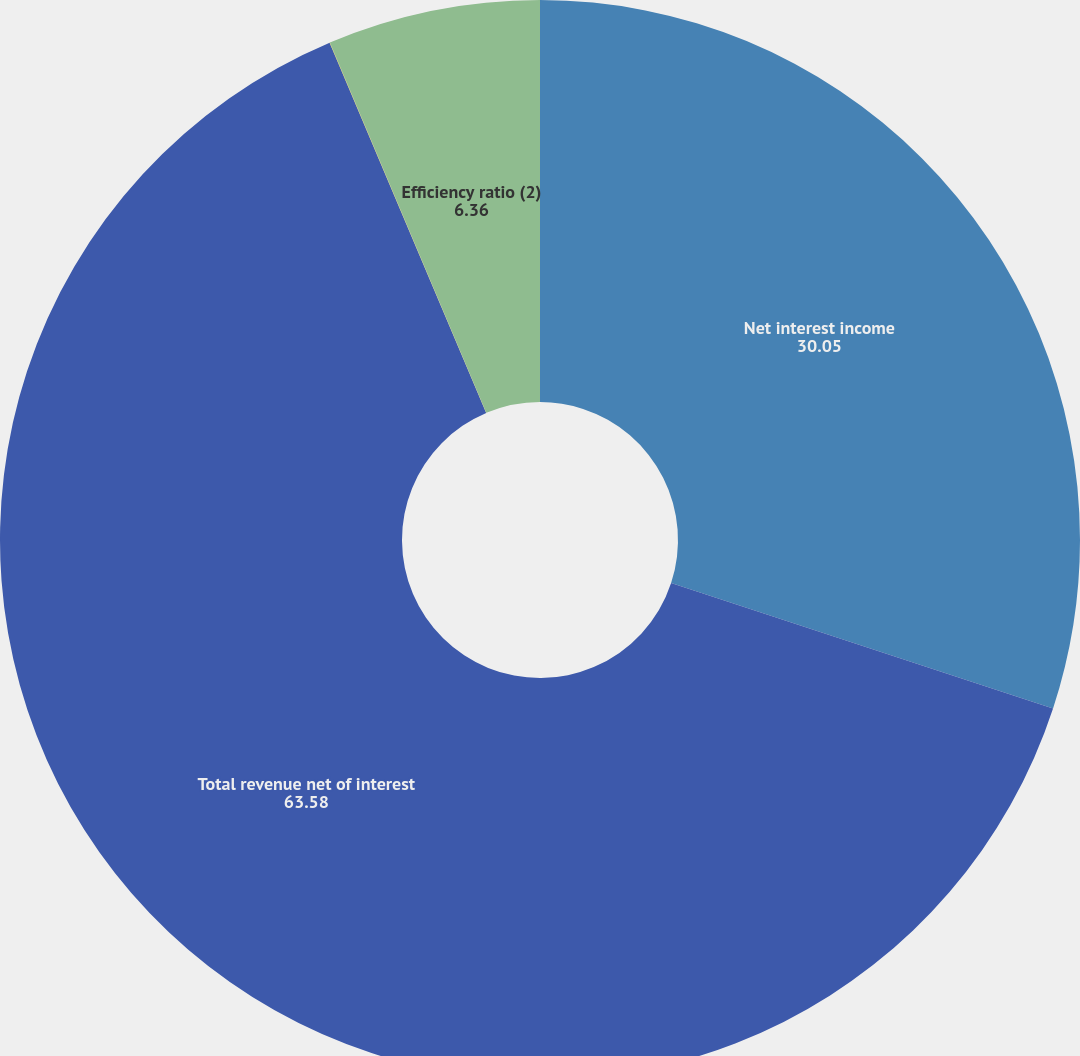<chart> <loc_0><loc_0><loc_500><loc_500><pie_chart><fcel>Net interest income<fcel>Total revenue net of interest<fcel>Net interest yield<fcel>Efficiency ratio (2)<nl><fcel>30.05%<fcel>63.58%<fcel>0.01%<fcel>6.36%<nl></chart> 